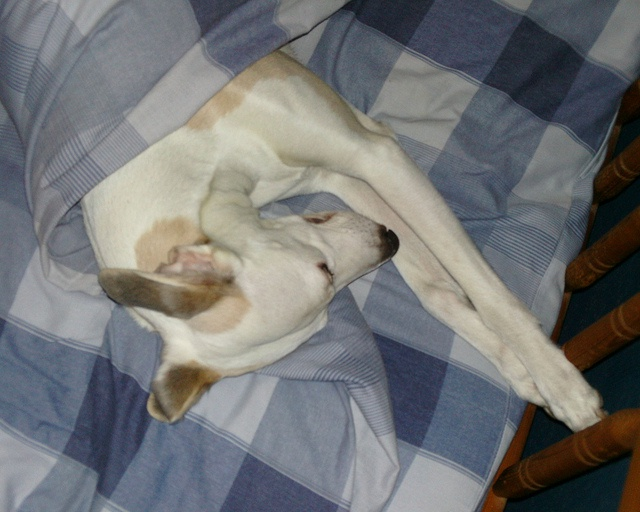Describe the objects in this image and their specific colors. I can see bed in gray, darkgray, and lightgray tones and dog in gray, darkgray, and lightgray tones in this image. 